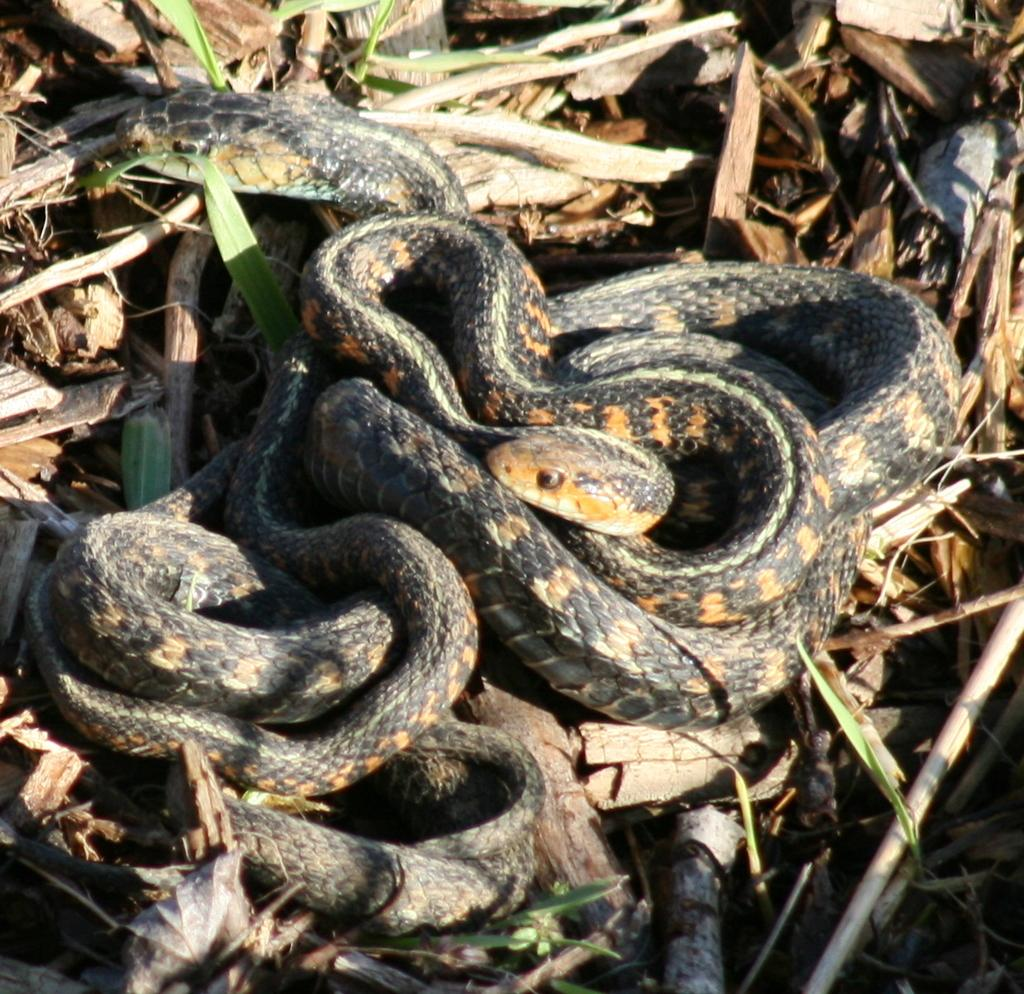What type of animals can be seen in the image? There are snakes in the image. Where are the snakes located? The snakes are on the land. What else can be seen in the image besides the snakes? There is trash visible in the image. What type of vegetation is present in the image? There is grass in the image. What type of dog can be seen playing with a unit in the image? There is no dog or unit present in the image; it features snakes on the land with trash and grass. 